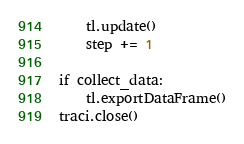<code> <loc_0><loc_0><loc_500><loc_500><_Python_>    tl.update()
    step += 1

if collect_data:
    tl.exportDataFrame()
traci.close()
</code> 